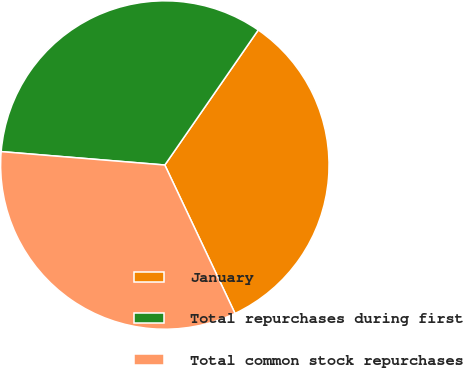Convert chart. <chart><loc_0><loc_0><loc_500><loc_500><pie_chart><fcel>January<fcel>Total repurchases during first<fcel>Total common stock repurchases<nl><fcel>33.33%<fcel>33.33%<fcel>33.33%<nl></chart> 